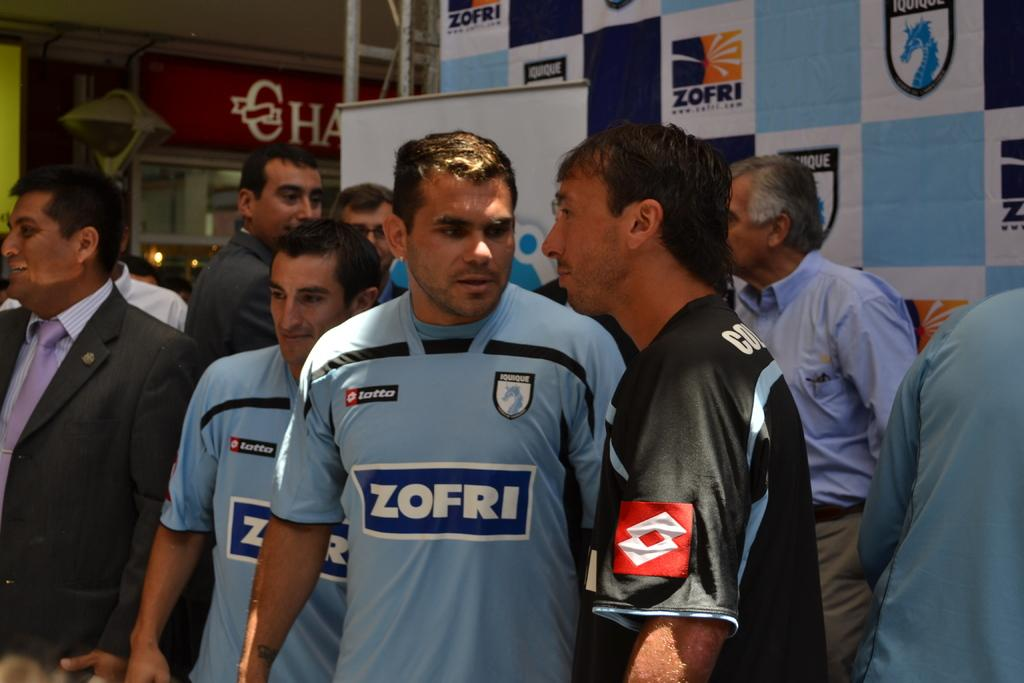Provide a one-sentence caption for the provided image. Athlete in blue with ZOFRI on the front standing next to an athlete in a black jersey. 